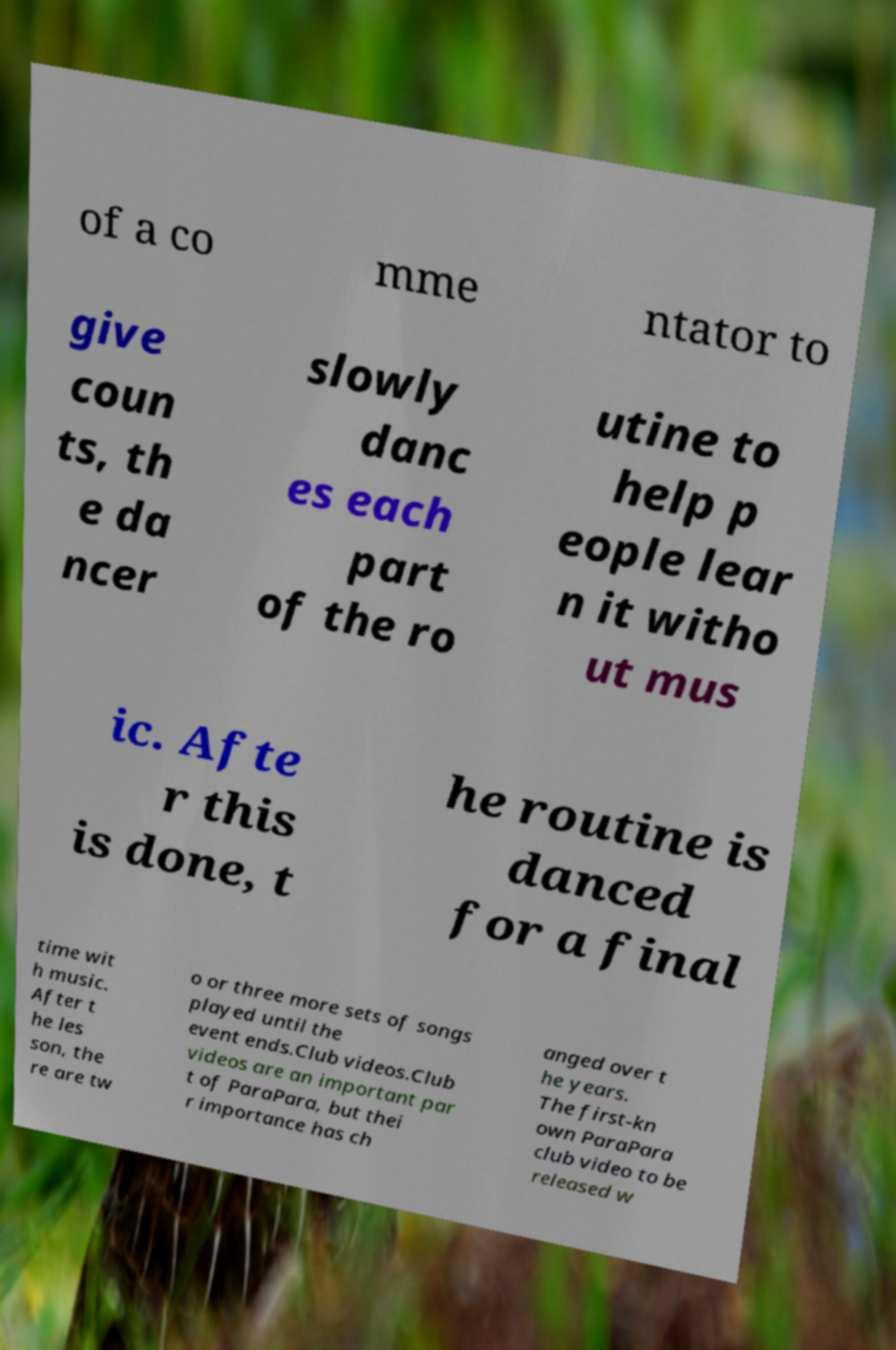Could you extract and type out the text from this image? of a co mme ntator to give coun ts, th e da ncer slowly danc es each part of the ro utine to help p eople lear n it witho ut mus ic. Afte r this is done, t he routine is danced for a final time wit h music. After t he les son, the re are tw o or three more sets of songs played until the event ends.Club videos.Club videos are an important par t of ParaPara, but thei r importance has ch anged over t he years. The first-kn own ParaPara club video to be released w 